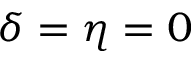Convert formula to latex. <formula><loc_0><loc_0><loc_500><loc_500>\delta = \eta = 0</formula> 